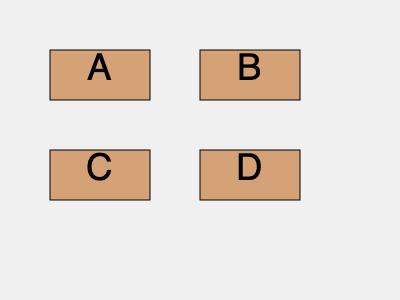Which two fragments, when combined, are most likely to form a complete line of text in a manuscript based on their edge patterns and content? To determine which two fragments are most likely to form a complete line of text, we need to analyze the edge patterns and potential content of each piece:

1. Fragment A: Has a straight edge on the left and right, suggesting it could be a middle section of text.
2. Fragment B: Has a straight edge on the left and an irregular edge on the right, indicating it might be the end of a line.
3. Fragment C: Has an irregular edge on the left and a straight edge on the right, suggesting it could be the beginning of a line.
4. Fragment D: Has straight edges on both sides, similar to fragment A, indicating it might be a middle section.

Based on these observations:

1. C and B are the most likely to form a complete line because:
   a. C appears to be a beginning piece (irregular left edge, straight right edge)
   b. B appears to be an ending piece (straight left edge, irregular right edge)
   c. When placed together, they would form a complete line with irregular edges on both ends

2. A and D are less likely to form a complete line because they both appear to be middle sections, lacking the characteristic beginning and end patterns.

Therefore, fragments C and B are the most likely to form a complete line of text when combined.
Answer: C and B 